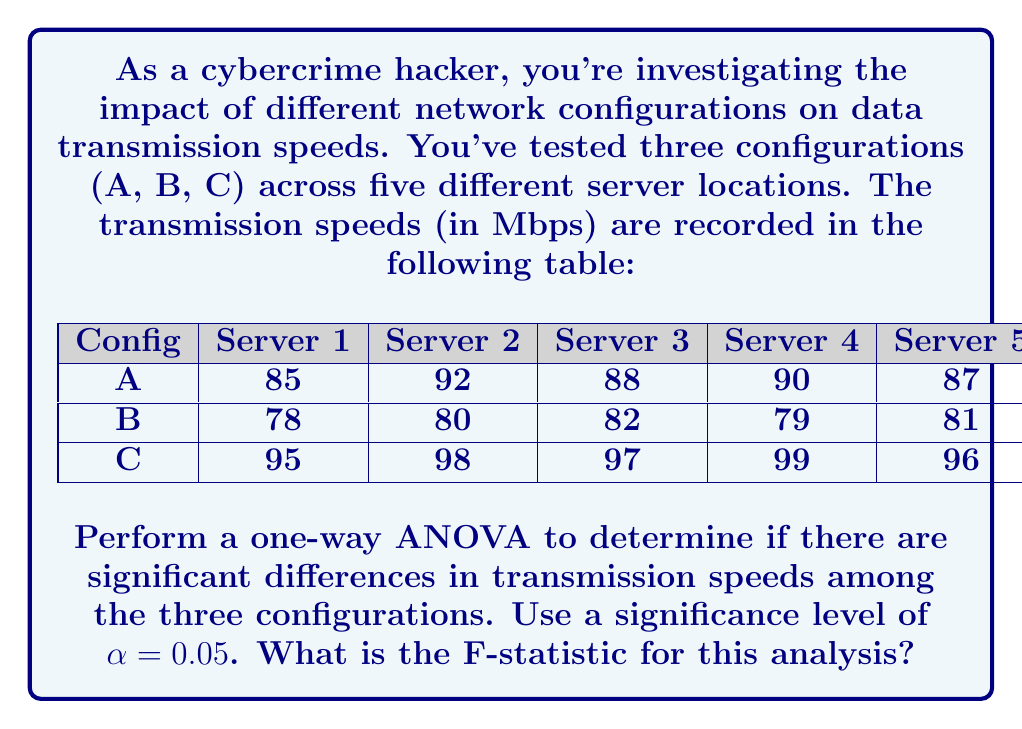What is the answer to this math problem? Let's approach this step-by-step:

1) First, we need to calculate the sum of squares:

   a) Total Sum of Squares (SST):
      $$SST = \sum_{i=1}^{n} (x_i - \bar{x})^2$$
      where $x_i$ are all individual values and $\bar{x}$ is the grand mean.

   b) Between-group Sum of Squares (SSB):
      $$SSB = \sum_{i=1}^{k} n_i(\bar{x}_i - \bar{x})^2$$
      where $k$ is the number of groups, $n_i$ is the size of each group, and $\bar{x}_i$ is the mean of each group.

   c) Within-group Sum of Squares (SSW):
      $$SSW = SST - SSB$$

2) Calculate the degrees of freedom:
   - Total df = n - 1 = 15 - 1 = 14
   - Between-group df = k - 1 = 3 - 1 = 2
   - Within-group df = n - k = 15 - 3 = 12

3) Calculate Mean Squares:
   $$MSB = \frac{SSB}{df_B}$$
   $$MSW = \frac{SSW}{df_W}$$

4) Calculate F-statistic:
   $$F = \frac{MSB}{MSW}$$

Now, let's perform the calculations:

1) a) Grand mean $\bar{x} = 88.47$
      SST = 1046.93

   b) Group means: $\bar{x}_A = 88.4$, $\bar{x}_B = 80$, $\bar{x}_C = 97$
      SSB = 907.73

   c) SSW = SST - SSB = 1046.93 - 907.73 = 139.2

2) Degrees of freedom are already calculated.

3) Mean Squares:
   MSB = 907.73 / 2 = 453.865
   MSW = 139.2 / 12 = 11.6

4) F-statistic:
   $$F = \frac{453.865}{11.6} = 39.13$$
Answer: 39.13 